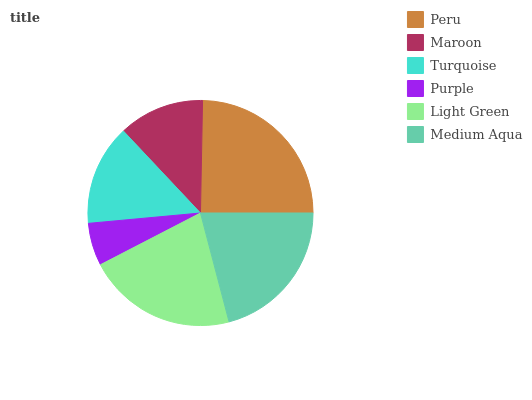Is Purple the minimum?
Answer yes or no. Yes. Is Peru the maximum?
Answer yes or no. Yes. Is Maroon the minimum?
Answer yes or no. No. Is Maroon the maximum?
Answer yes or no. No. Is Peru greater than Maroon?
Answer yes or no. Yes. Is Maroon less than Peru?
Answer yes or no. Yes. Is Maroon greater than Peru?
Answer yes or no. No. Is Peru less than Maroon?
Answer yes or no. No. Is Medium Aqua the high median?
Answer yes or no. Yes. Is Turquoise the low median?
Answer yes or no. Yes. Is Turquoise the high median?
Answer yes or no. No. Is Maroon the low median?
Answer yes or no. No. 